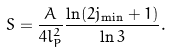Convert formula to latex. <formula><loc_0><loc_0><loc_500><loc_500>S = \frac { A } { 4 l _ { P } ^ { 2 } } \frac { \ln ( 2 j _ { \min } + 1 ) } { \ln 3 } .</formula> 